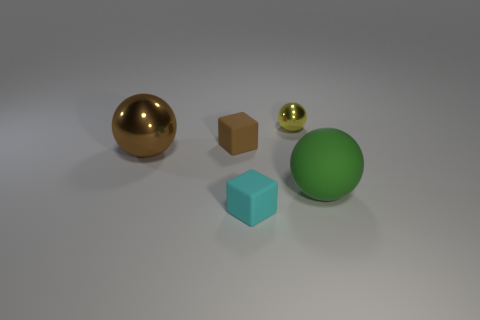Are there more big matte things to the left of the small cyan rubber block than green things? Upon reviewing the image, to the left of the small cyan rubber block there appears to be one large gold sphere and one medium-sized brown cube, making two big matte things in total. In comparison, there is one large green sphere in the scene, so there are more big matte things to the left of the small cyan block than green things. 